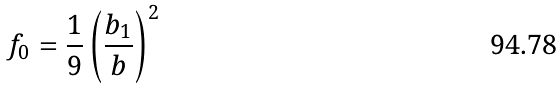<formula> <loc_0><loc_0><loc_500><loc_500>f _ { 0 } = \frac { 1 } { 9 } \left ( \frac { b _ { 1 } } b \right ) ^ { 2 }</formula> 